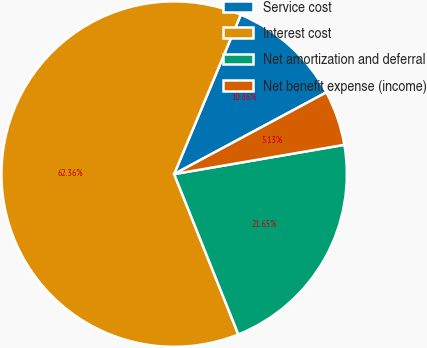Convert chart to OTSL. <chart><loc_0><loc_0><loc_500><loc_500><pie_chart><fcel>Service cost<fcel>Interest cost<fcel>Net amortization and deferral<fcel>Net benefit expense (income)<nl><fcel>10.86%<fcel>62.36%<fcel>21.65%<fcel>5.13%<nl></chart> 